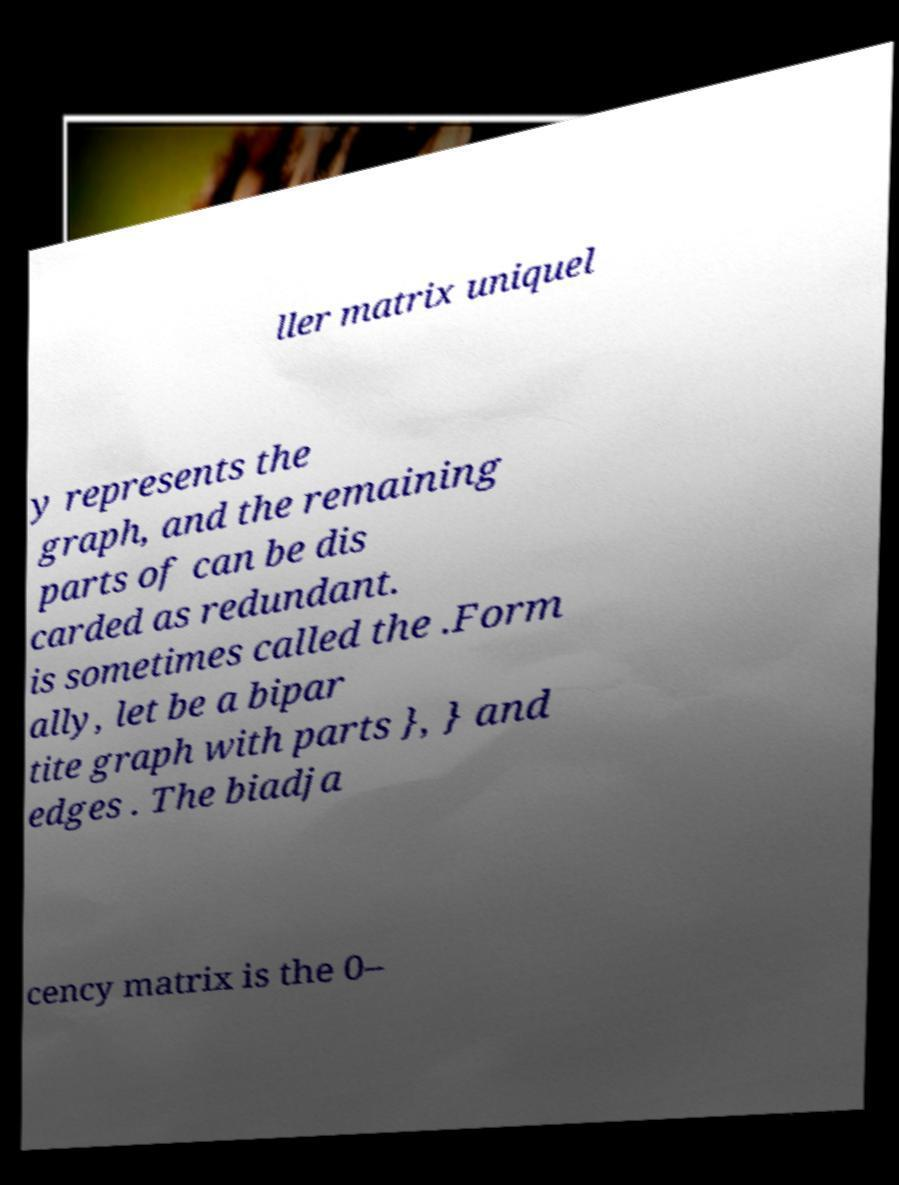I need the written content from this picture converted into text. Can you do that? ller matrix uniquel y represents the graph, and the remaining parts of can be dis carded as redundant. is sometimes called the .Form ally, let be a bipar tite graph with parts }, } and edges . The biadja cency matrix is the 0– 